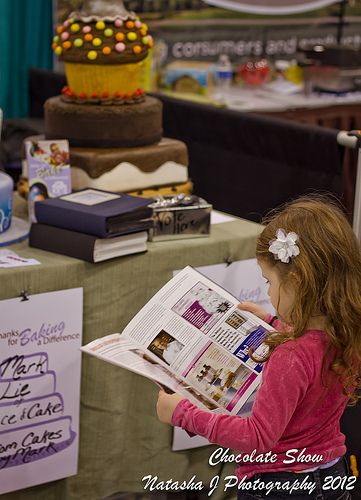Are there either farmers or customers in this scene? No, the image does not feature any farmers or customers, focusing instead on a child at a dessert show. 